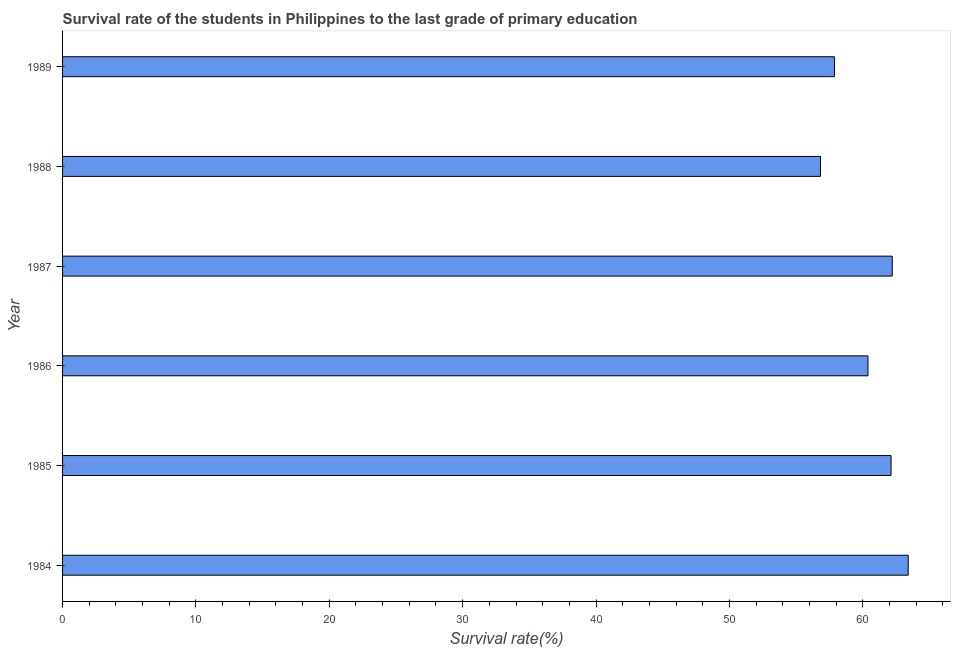What is the title of the graph?
Your answer should be very brief. Survival rate of the students in Philippines to the last grade of primary education. What is the label or title of the X-axis?
Ensure brevity in your answer.  Survival rate(%). What is the survival rate in primary education in 1984?
Ensure brevity in your answer.  63.41. Across all years, what is the maximum survival rate in primary education?
Your answer should be very brief. 63.41. Across all years, what is the minimum survival rate in primary education?
Give a very brief answer. 56.83. In which year was the survival rate in primary education minimum?
Ensure brevity in your answer.  1988. What is the sum of the survival rate in primary education?
Provide a short and direct response. 362.84. What is the difference between the survival rate in primary education in 1984 and 1986?
Provide a succinct answer. 3.02. What is the average survival rate in primary education per year?
Your answer should be compact. 60.47. What is the median survival rate in primary education?
Your response must be concise. 61.26. In how many years, is the survival rate in primary education greater than 4 %?
Offer a terse response. 6. What is the ratio of the survival rate in primary education in 1986 to that in 1988?
Your answer should be compact. 1.06. What is the difference between the highest and the second highest survival rate in primary education?
Make the answer very short. 1.2. What is the difference between the highest and the lowest survival rate in primary education?
Your response must be concise. 6.58. In how many years, is the survival rate in primary education greater than the average survival rate in primary education taken over all years?
Give a very brief answer. 3. How many bars are there?
Keep it short and to the point. 6. Are all the bars in the graph horizontal?
Ensure brevity in your answer.  Yes. How many years are there in the graph?
Your answer should be compact. 6. Are the values on the major ticks of X-axis written in scientific E-notation?
Your answer should be very brief. No. What is the Survival rate(%) of 1984?
Provide a short and direct response. 63.41. What is the Survival rate(%) of 1985?
Give a very brief answer. 62.12. What is the Survival rate(%) of 1986?
Ensure brevity in your answer.  60.39. What is the Survival rate(%) in 1987?
Your response must be concise. 62.21. What is the Survival rate(%) in 1988?
Make the answer very short. 56.83. What is the Survival rate(%) of 1989?
Your answer should be compact. 57.88. What is the difference between the Survival rate(%) in 1984 and 1985?
Provide a succinct answer. 1.29. What is the difference between the Survival rate(%) in 1984 and 1986?
Offer a terse response. 3.02. What is the difference between the Survival rate(%) in 1984 and 1987?
Offer a terse response. 1.2. What is the difference between the Survival rate(%) in 1984 and 1988?
Offer a very short reply. 6.58. What is the difference between the Survival rate(%) in 1984 and 1989?
Ensure brevity in your answer.  5.53. What is the difference between the Survival rate(%) in 1985 and 1986?
Give a very brief answer. 1.73. What is the difference between the Survival rate(%) in 1985 and 1987?
Offer a very short reply. -0.09. What is the difference between the Survival rate(%) in 1985 and 1988?
Offer a very short reply. 5.29. What is the difference between the Survival rate(%) in 1985 and 1989?
Offer a very short reply. 4.25. What is the difference between the Survival rate(%) in 1986 and 1987?
Offer a terse response. -1.82. What is the difference between the Survival rate(%) in 1986 and 1988?
Provide a short and direct response. 3.56. What is the difference between the Survival rate(%) in 1986 and 1989?
Ensure brevity in your answer.  2.51. What is the difference between the Survival rate(%) in 1987 and 1988?
Ensure brevity in your answer.  5.38. What is the difference between the Survival rate(%) in 1987 and 1989?
Offer a very short reply. 4.33. What is the difference between the Survival rate(%) in 1988 and 1989?
Keep it short and to the point. -1.05. What is the ratio of the Survival rate(%) in 1984 to that in 1988?
Ensure brevity in your answer.  1.12. What is the ratio of the Survival rate(%) in 1984 to that in 1989?
Keep it short and to the point. 1.1. What is the ratio of the Survival rate(%) in 1985 to that in 1986?
Give a very brief answer. 1.03. What is the ratio of the Survival rate(%) in 1985 to that in 1988?
Provide a short and direct response. 1.09. What is the ratio of the Survival rate(%) in 1985 to that in 1989?
Make the answer very short. 1.07. What is the ratio of the Survival rate(%) in 1986 to that in 1988?
Ensure brevity in your answer.  1.06. What is the ratio of the Survival rate(%) in 1986 to that in 1989?
Give a very brief answer. 1.04. What is the ratio of the Survival rate(%) in 1987 to that in 1988?
Give a very brief answer. 1.09. What is the ratio of the Survival rate(%) in 1987 to that in 1989?
Ensure brevity in your answer.  1.07. What is the ratio of the Survival rate(%) in 1988 to that in 1989?
Your answer should be very brief. 0.98. 